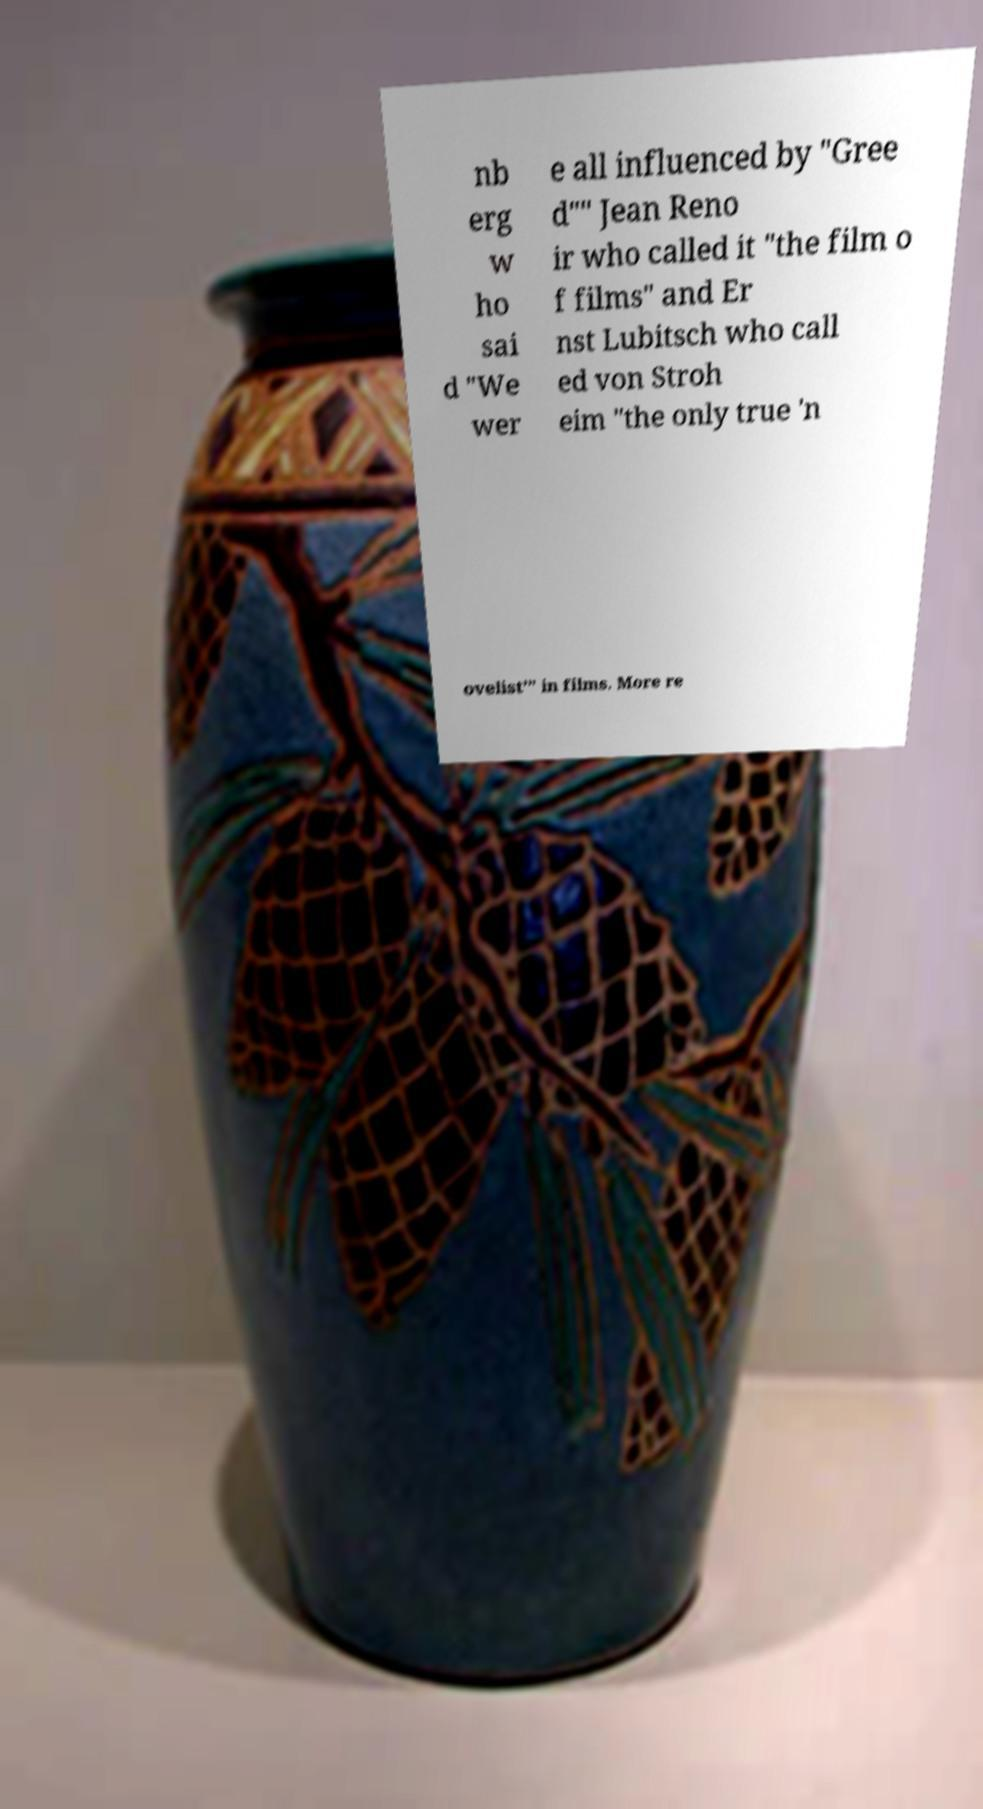Could you extract and type out the text from this image? nb erg w ho sai d "We wer e all influenced by "Gree d"" Jean Reno ir who called it "the film o f films" and Er nst Lubitsch who call ed von Stroh eim "the only true 'n ovelist'" in films. More re 